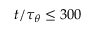Convert formula to latex. <formula><loc_0><loc_0><loc_500><loc_500>t / { \tau _ { \theta } } \leq 3 0 0</formula> 